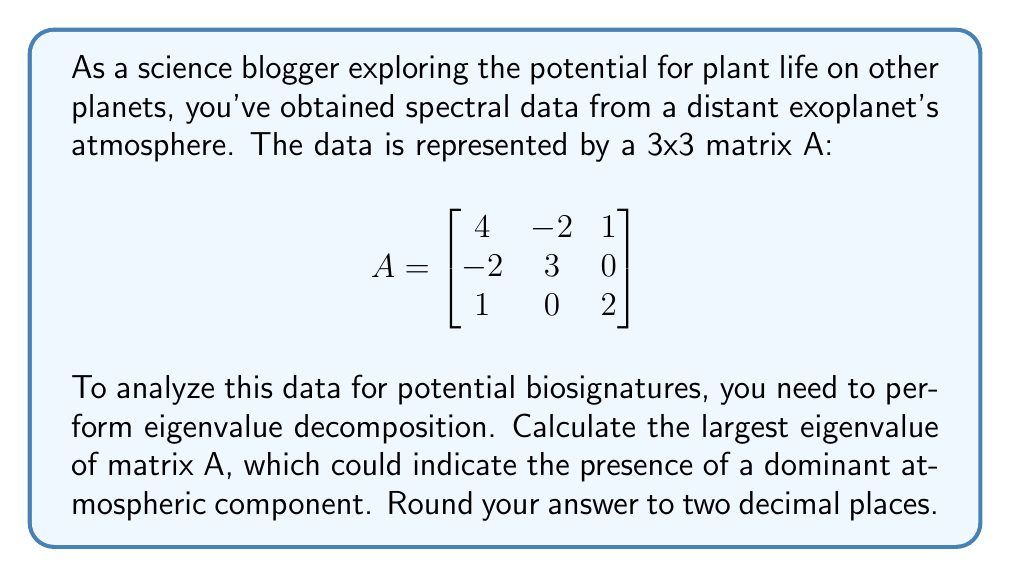What is the answer to this math problem? To find the largest eigenvalue of matrix A, we'll follow these steps:

1) First, we need to find the characteristic equation of A. The characteristic equation is given by:

   $$det(A - \lambda I) = 0$$

   where I is the 3x3 identity matrix and λ represents the eigenvalues.

2) Expanding this, we get:

   $$\begin{vmatrix}
   4-\lambda & -2 & 1 \\
   -2 & 3-\lambda & 0 \\
   1 & 0 & 2-\lambda
   \end{vmatrix} = 0$$

3) Calculating the determinant:

   $$(4-\lambda)(3-\lambda)(2-\lambda) + (-2)(0)(1) + (-2)(1)(0) - (1)(3-\lambda)(1) - (4-\lambda)(0)(0) - (-2)(-2)(2-\lambda) = 0$$

4) Simplifying:

   $$(4-\lambda)(3-\lambda)(2-\lambda) - (3-\lambda) - 4(2-\lambda) = 0$$

   $$24 - 18\lambda + 4\lambda^2 - \lambda^3 - 3 + \lambda - 8 + 4\lambda = 0$$

   $$-\lambda^3 + 4\lambda^2 - 13\lambda + 13 = 0$$

5) This is a cubic equation. To solve it, we can use the cubic formula or numerical methods. Using a calculator or computer algebra system, we find that the roots (eigenvalues) are approximately:

   $$\lambda_1 \approx 5.5616$$
   $$\lambda_2 \approx 2.1912$$
   $$\lambda_3 \approx 1.2472$$

6) The largest eigenvalue is λ₁ ≈ 5.5616.

7) Rounding to two decimal places, we get 5.56.
Answer: 5.56 